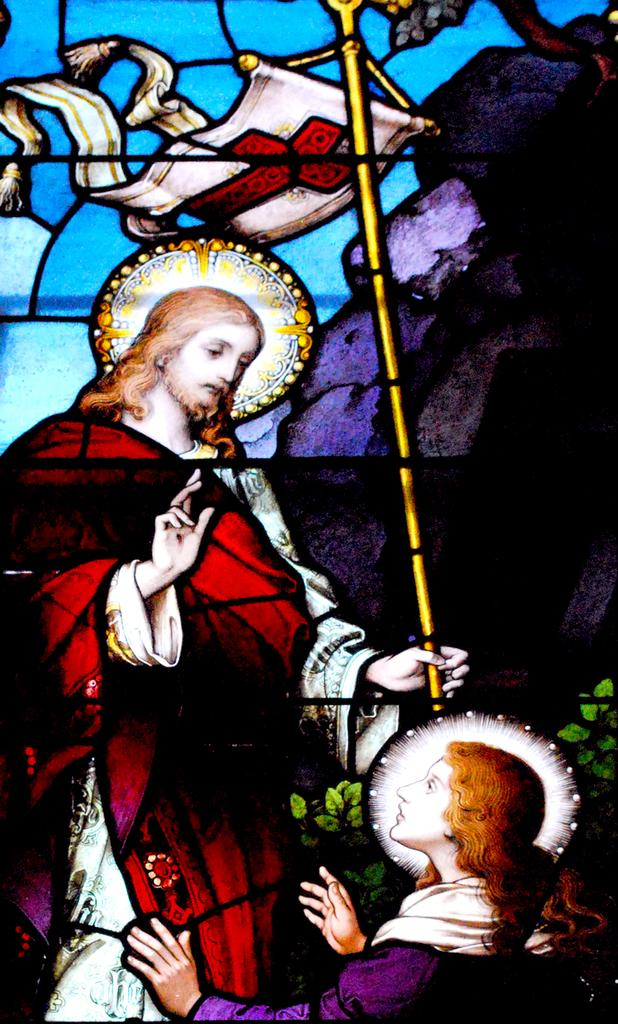What is the main subject of the image? There is a picture in the image. Who or what is depicted in the picture? The picture contains Jesus. Are there any other people or objects in the picture? Yes, there is a man in the picture. What can be seen in the background of the image? The sky is visible in the background of the image. What type of flag is being waved by Jesus in the image? There is no flag present in the image, and Jesus is not depicted as waving anything. 